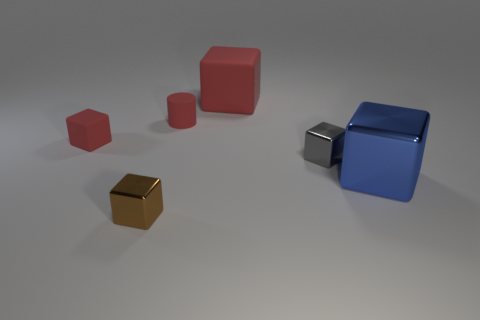What is the color of the cylinder that is the same material as the big red object? The cylinder that shares the same glossy material characteristic as the large red cube is also red in color, exhibiting a coherence in hue and finish between the two objects. 